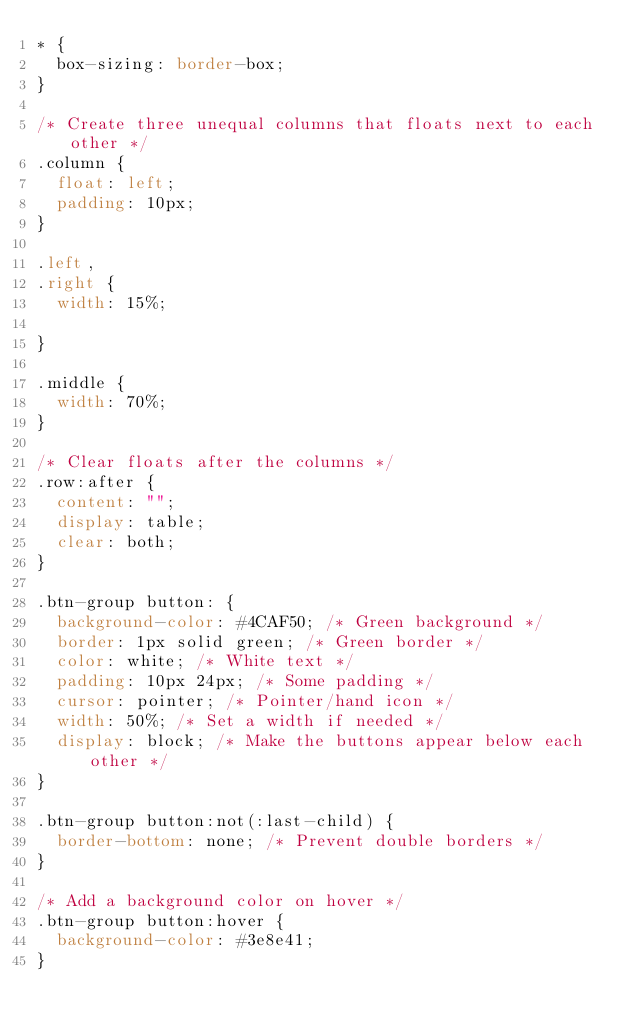<code> <loc_0><loc_0><loc_500><loc_500><_CSS_>* {
  box-sizing: border-box;
}

/* Create three unequal columns that floats next to each other */
.column {
  float: left;
  padding: 10px;
}

.left,
.right {
  width: 15%;

}

.middle {
  width: 70%;
}

/* Clear floats after the columns */
.row:after {
  content: "";
  display: table;
  clear: both;
}

.btn-group button: {
  background-color: #4CAF50; /* Green background */
  border: 1px solid green; /* Green border */
  color: white; /* White text */
  padding: 10px 24px; /* Some padding */
  cursor: pointer; /* Pointer/hand icon */
  width: 50%; /* Set a width if needed */
  display: block; /* Make the buttons appear below each other */
}

.btn-group button:not(:last-child) {
  border-bottom: none; /* Prevent double borders */
}

/* Add a background color on hover */
.btn-group button:hover {
  background-color: #3e8e41;
}
</code> 